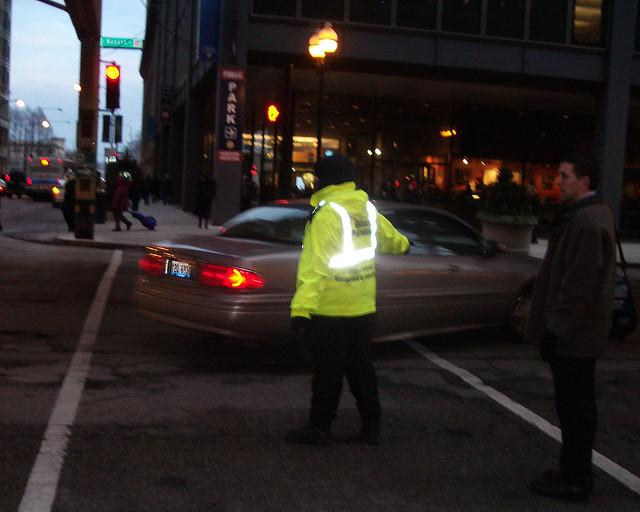Why is the man wearing a reflective jacket? Please explain your reasoning. visibility. The yellow jacket allows people to see him at night so he can be near traffic. 